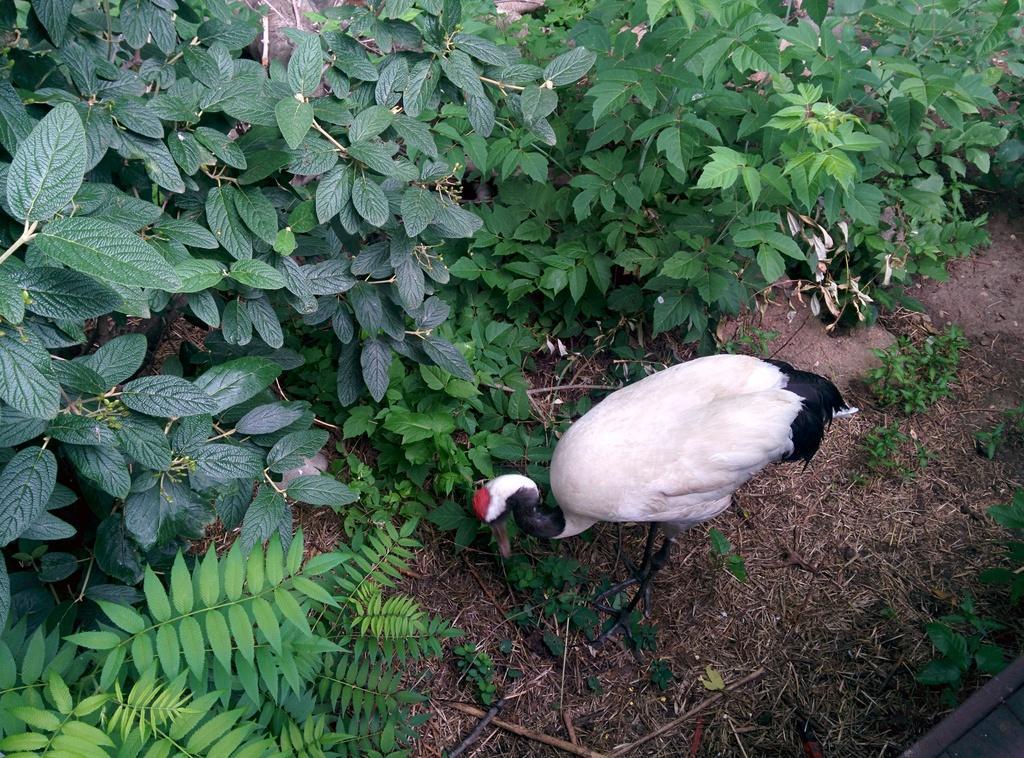How would you summarize this image in a sentence or two? Here we can see a bird and there are plants. 